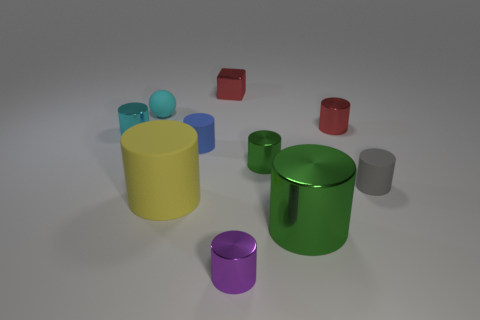There is a cylinder that is the same color as the ball; what is it made of?
Your response must be concise. Metal. Is there anything else that has the same color as the metallic block?
Offer a terse response. Yes. There is a metal object that is both in front of the cyan metal thing and behind the big green thing; what size is it?
Your answer should be compact. Small. Is the shape of the large object left of the small blue cylinder the same as the small shiny thing in front of the gray matte cylinder?
Keep it short and to the point. Yes. The thing that is the same color as the rubber sphere is what shape?
Your answer should be very brief. Cylinder. How many green cylinders are made of the same material as the cyan sphere?
Provide a short and direct response. 0. What is the shape of the tiny object that is both on the left side of the tiny blue cylinder and behind the cyan metallic cylinder?
Your answer should be compact. Sphere. Are the small cylinder in front of the gray rubber object and the big yellow cylinder made of the same material?
Offer a terse response. No. What color is the sphere that is the same size as the red cube?
Give a very brief answer. Cyan. Are there any shiny things that have the same color as the tiny shiny cube?
Make the answer very short. Yes. 